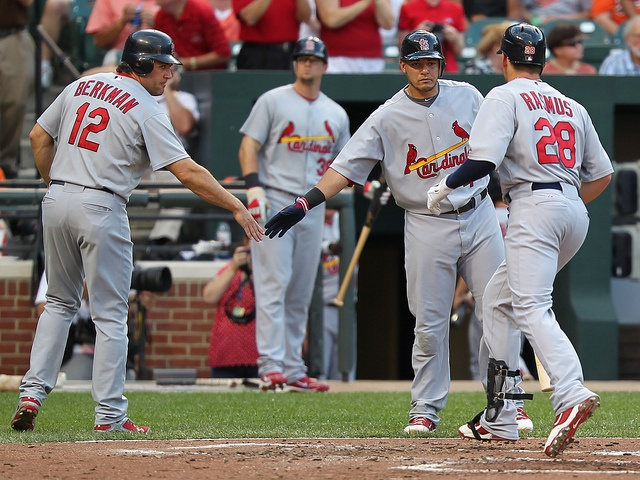Describe the objects in this image and their specific colors. I can see people in black, darkgray, gray, and lightgray tones, people in black, lightgray, darkgray, and gray tones, people in black, darkgray, gray, and lightgray tones, people in black, darkgray, gray, and brown tones, and people in black, brown, maroon, and gray tones in this image. 